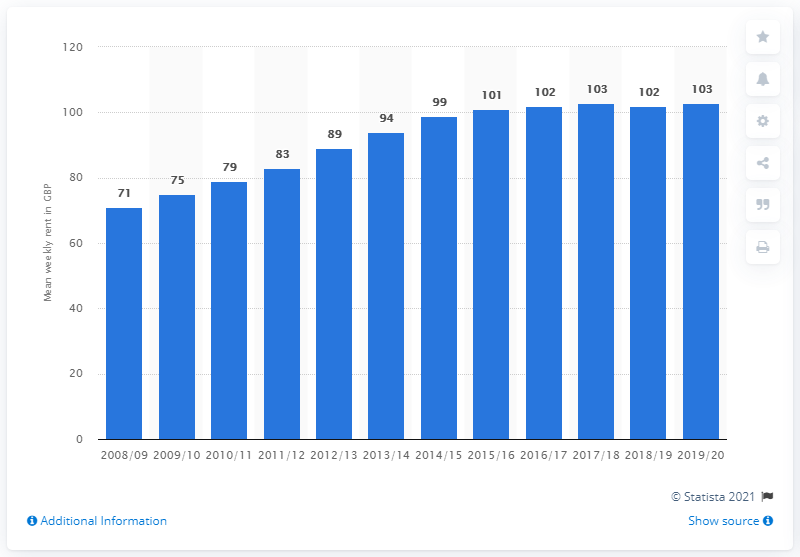Indicate a few pertinent items in this graphic. The average weekly rent of social renters in England from 2008 to 2020 was 103. The average weekly rent of social renters in England in 2008 was 71 pounds. 